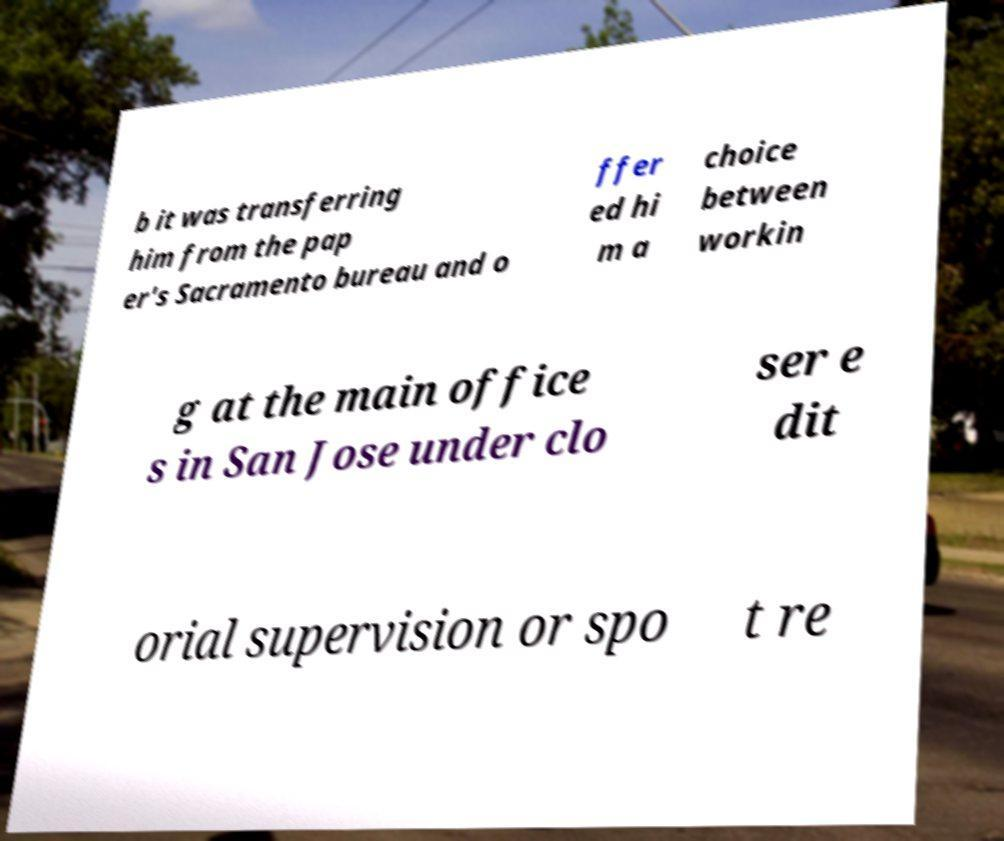Please identify and transcribe the text found in this image. b it was transferring him from the pap er's Sacramento bureau and o ffer ed hi m a choice between workin g at the main office s in San Jose under clo ser e dit orial supervision or spo t re 